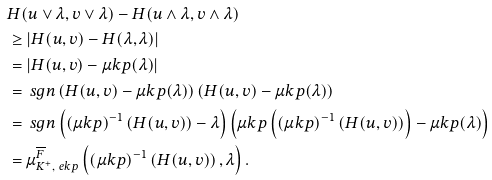Convert formula to latex. <formula><loc_0><loc_0><loc_500><loc_500>& H ( u \vee \lambda , v \vee \lambda ) - H ( u \wedge \lambda , v \wedge \lambda ) \\ & \geq \left | H ( u , v ) - H ( \lambda , \lambda ) \right | \\ & = \left | H ( u , v ) - \mu k p ( \lambda ) \right | \\ & = \ s g n \left ( H ( u , v ) - \mu k p ( \lambda ) \right ) \left ( H ( u , v ) - \mu k p ( \lambda ) \right ) \\ & = \ s g n \left ( ( \mu k p ) ^ { - 1 } \left ( H ( u , v ) \right ) - \lambda \right ) \left ( \mu k p \left ( ( \mu k p ) ^ { - 1 } \left ( H ( u , v ) \right ) \right ) - \mu k p ( \lambda ) \right ) \\ & = \mu ^ { \overline { F } } _ { K ^ { + } , \ e k p } \left ( ( \mu k p ) ^ { - 1 } \left ( H ( u , v ) \right ) , \lambda \right ) .</formula> 